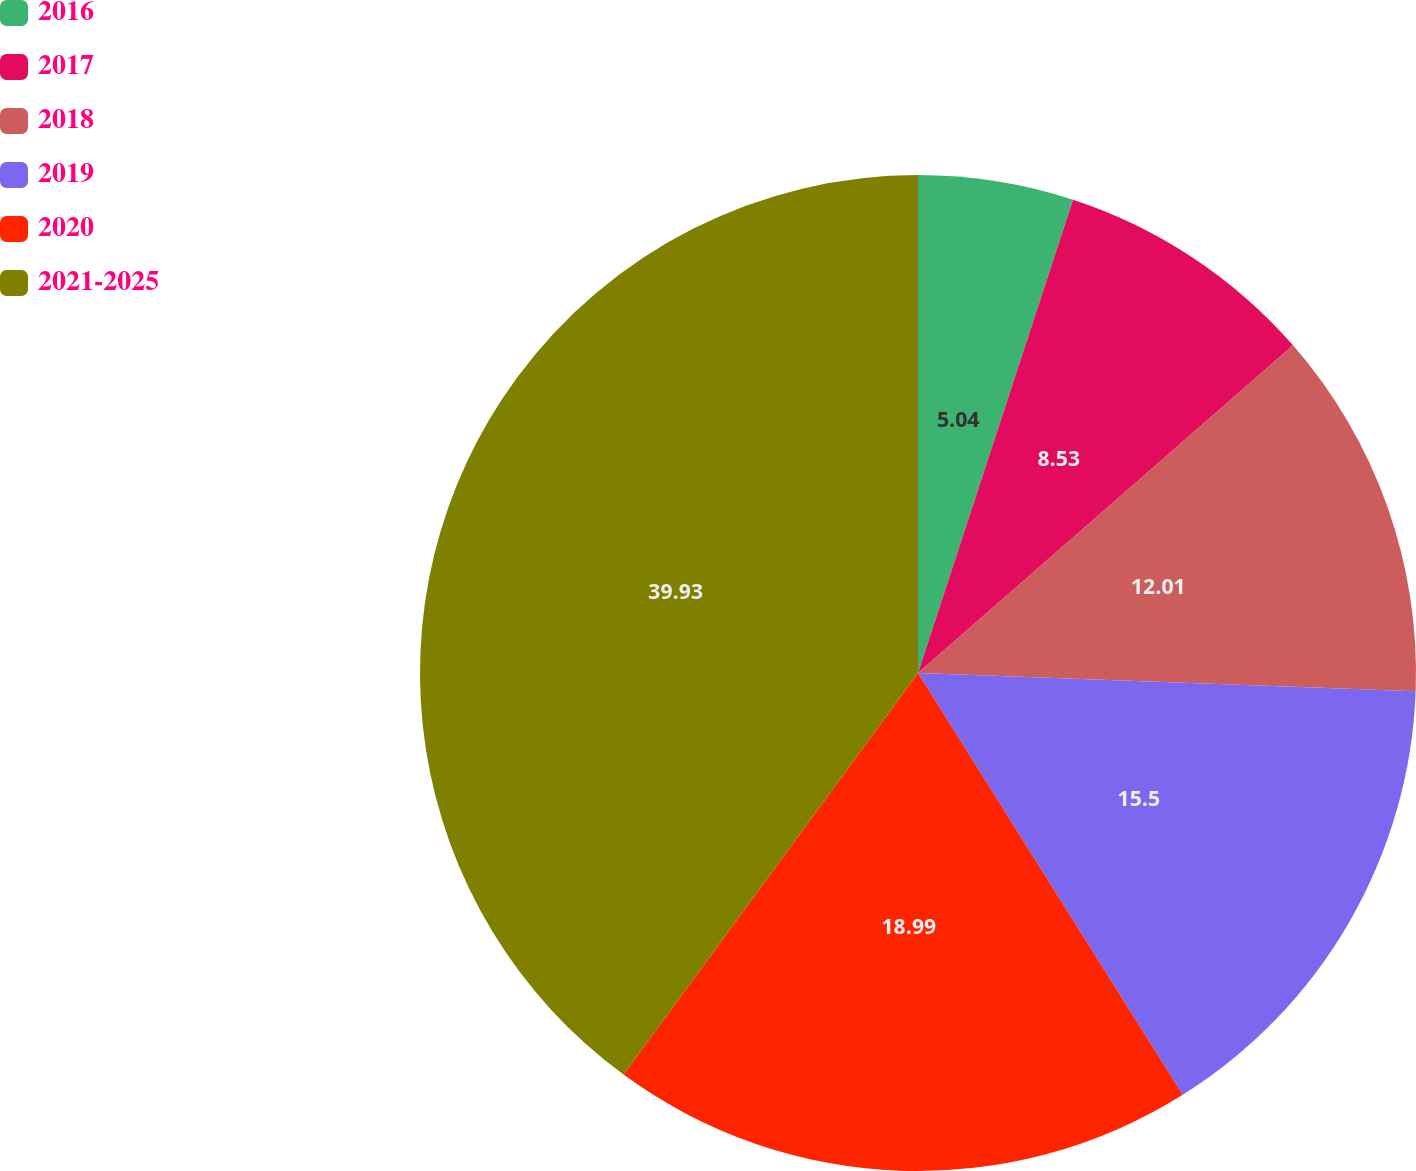Convert chart. <chart><loc_0><loc_0><loc_500><loc_500><pie_chart><fcel>2016<fcel>2017<fcel>2018<fcel>2019<fcel>2020<fcel>2021-2025<nl><fcel>5.04%<fcel>8.53%<fcel>12.01%<fcel>15.5%<fcel>18.99%<fcel>39.93%<nl></chart> 